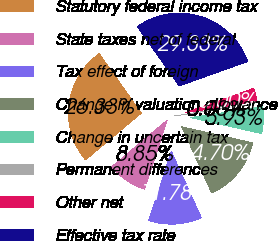Convert chart. <chart><loc_0><loc_0><loc_500><loc_500><pie_chart><fcel>Statutory federal income tax<fcel>State taxes net of federal<fcel>Tax effect of foreign<fcel>Change in valuation allowance<fcel>Change in uncertain tax<fcel>Permanent differences<fcel>Other net<fcel>Effective tax rate<nl><fcel>26.33%<fcel>8.85%<fcel>11.78%<fcel>14.7%<fcel>5.93%<fcel>0.08%<fcel>3.0%<fcel>29.33%<nl></chart> 